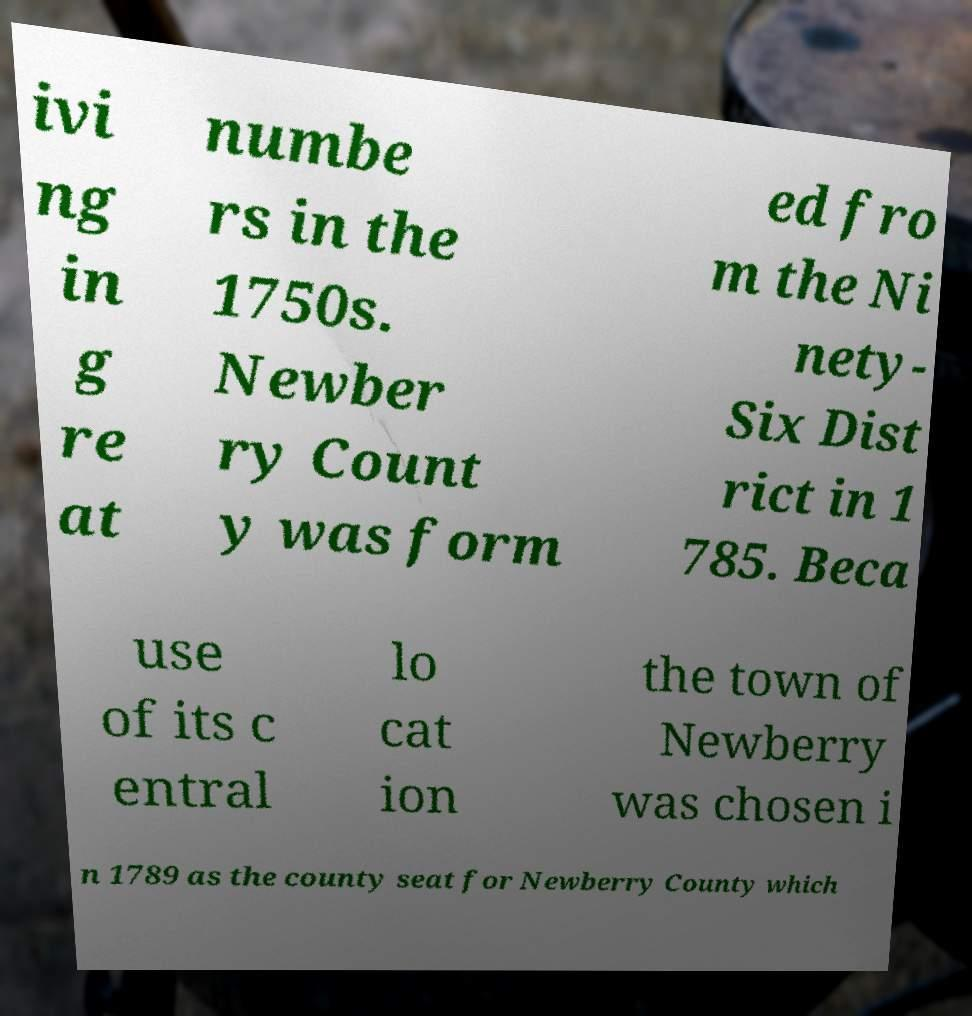Could you assist in decoding the text presented in this image and type it out clearly? ivi ng in g re at numbe rs in the 1750s. Newber ry Count y was form ed fro m the Ni nety- Six Dist rict in 1 785. Beca use of its c entral lo cat ion the town of Newberry was chosen i n 1789 as the county seat for Newberry County which 